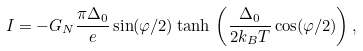<formula> <loc_0><loc_0><loc_500><loc_500>I = - G _ { N } \frac { \pi \Delta _ { 0 } } { e } \sin ( \varphi / 2 ) \tanh \, \left ( \frac { \Delta _ { 0 } } { 2 k _ { B } T } \cos ( \varphi / 2 ) \right ) ,</formula> 